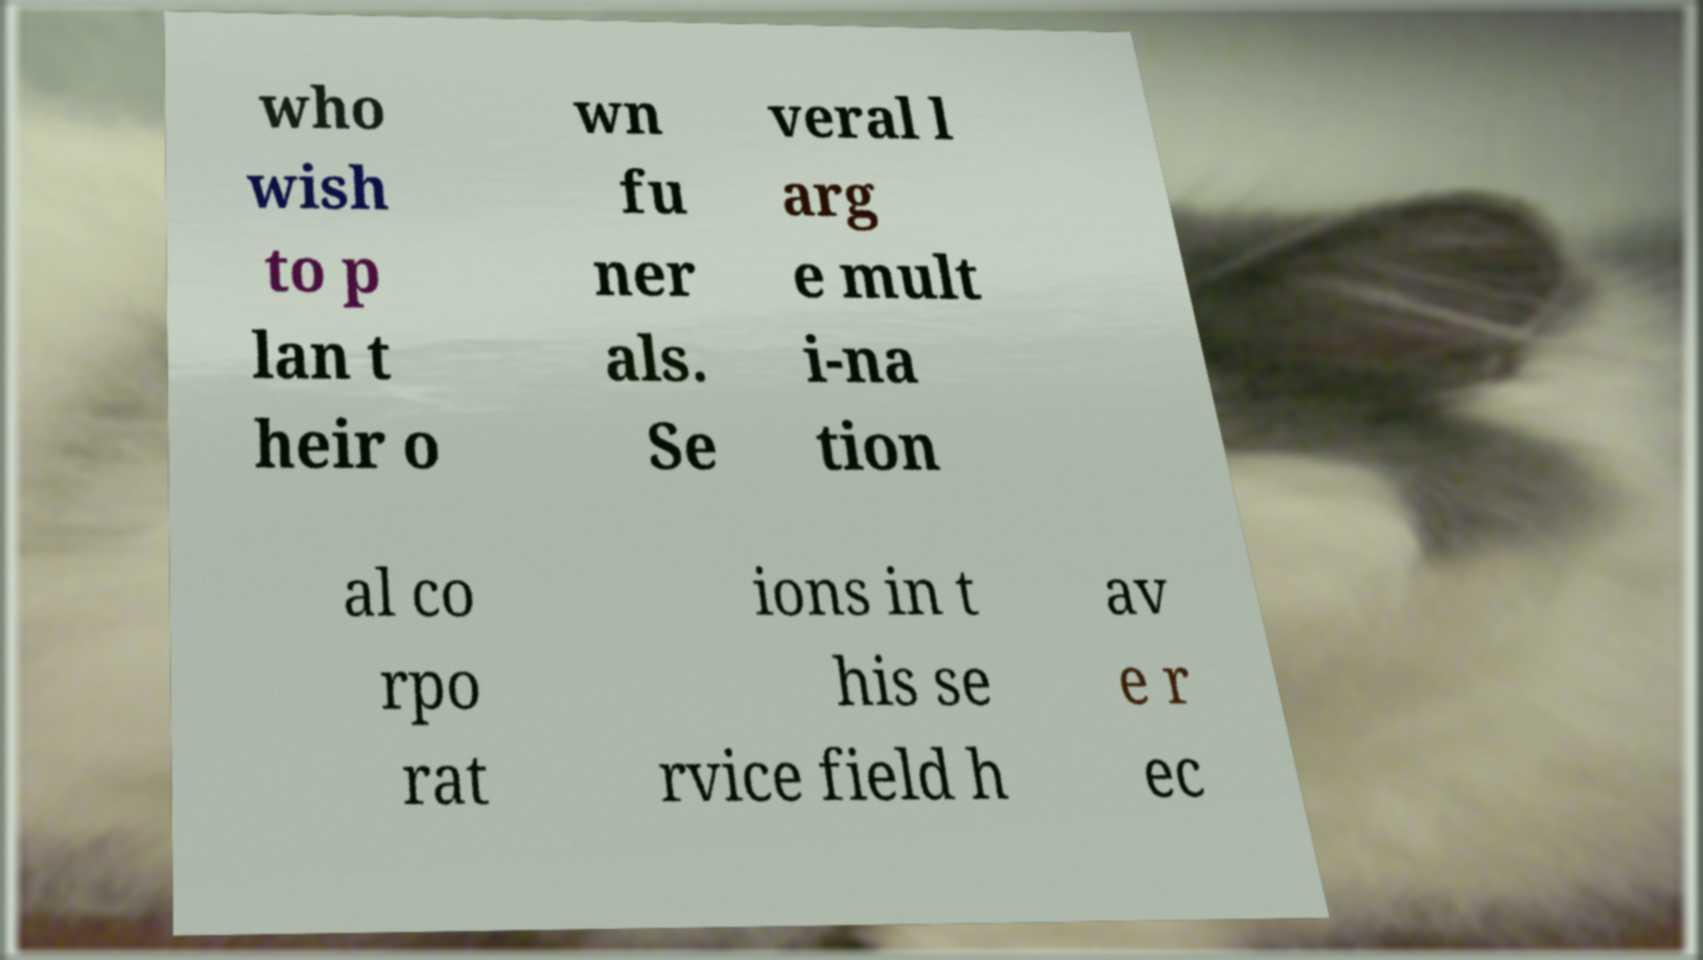Could you assist in decoding the text presented in this image and type it out clearly? who wish to p lan t heir o wn fu ner als. Se veral l arg e mult i-na tion al co rpo rat ions in t his se rvice field h av e r ec 